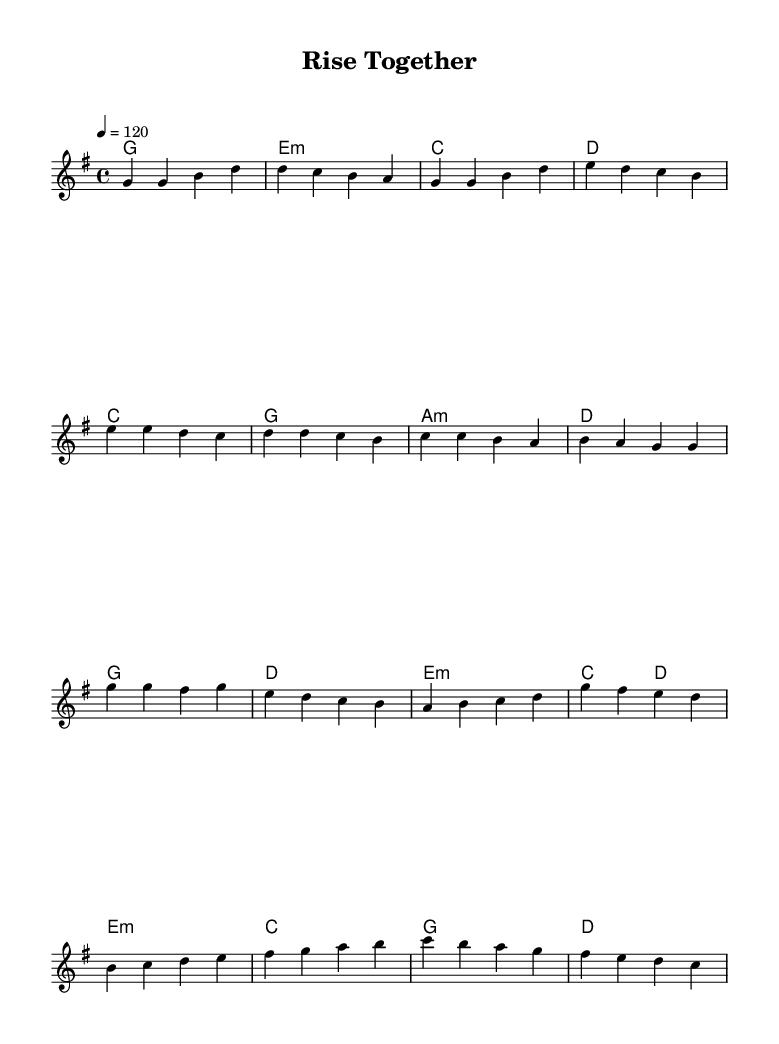What is the key signature of this music? The key signature is G major, which has one sharp (F#). This can be determined by looking at the notation at the beginning of the staff, where the key signature is indicated.
Answer: G major What is the time signature of this piece? The time signature is 4/4, which indicates four beats per measure, with a quarter note receiving one beat. This is clearly indicated at the beginning of the sheet music.
Answer: 4/4 What is the tempo marking in the music? The tempo marking is "4 = 120," indicating that there are 120 beats per minute, with the quarter note being the beat unit. This is written at the beginning of the score under the tempo text.
Answer: 120 What are the lyrics for the chorus? The lyrics for the chorus are "We rise together, stronger than before, Breaking through barriers, opening new doors." This is derived from the lyric section that corresponds to the chorus section of the melody.
Answer: We rise together, stronger than before, Breaking through barriers, opening new doors How many measures are in the verse section? The verse section contains four measures, which can be counted by looking at the notated measures in the melody line. Each group of numbers indicates one measure.
Answer: 4 What harmonies are used in the pre-chorus? The harmonies used in the pre-chorus are C, G, A minor, and D. This can be found in the chord mode section that lists the chords corresponding to that part of the song.
Answer: C, G, A minor, D What is the primary theme of the lyrics? The primary theme of the lyrics is about unity and overcoming challenges together. This can be discerned by analyzing the words and phrases throughout the verses and chorus, which focus on standing together and growing stronger.
Answer: Unity and overcoming challenges 